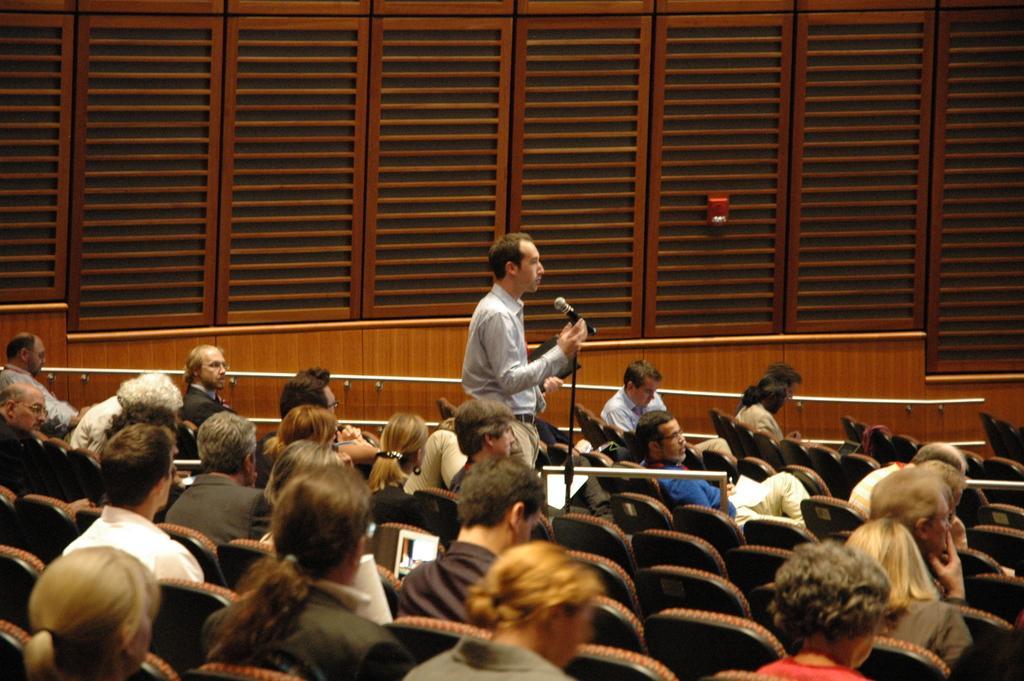What are the people in the image doing? The people in the image are sitting on chairs. Is there anyone standing in the image? Yes, there is at least one person standing in the image. What is the standing person holding? The standing person is holding a microphone. What type of windows can be seen in the image? Wooden windows are visible in the image. How many pickles are on the table in the image? There is no mention of pickles or a table in the image, so it is impossible to determine the number of pickles present. 